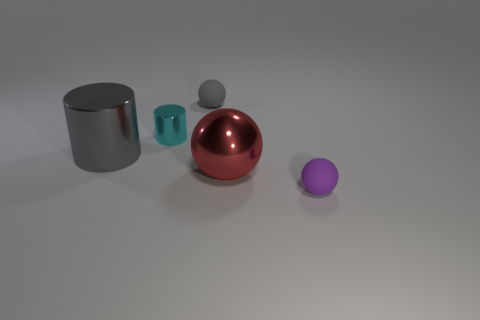Subtract all small rubber balls. How many balls are left? 1 Subtract all spheres. How many objects are left? 2 Add 1 tiny rubber balls. How many objects exist? 6 Add 2 small gray balls. How many small gray balls exist? 3 Subtract 1 purple spheres. How many objects are left? 4 Subtract all purple matte balls. Subtract all gray spheres. How many objects are left? 3 Add 1 red shiny objects. How many red shiny objects are left? 2 